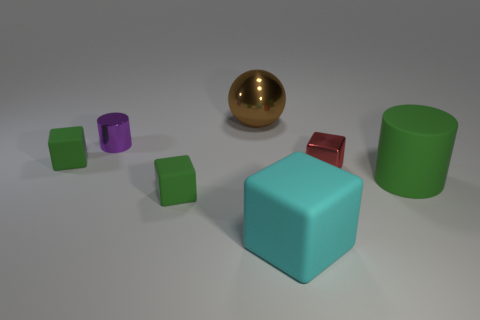Could you describe the lighting in this scene? The scene is lit with diffuse overhead lighting, creating soft shadows beneath the objects and giving the scene a calm, evenly illuminated appearance. 